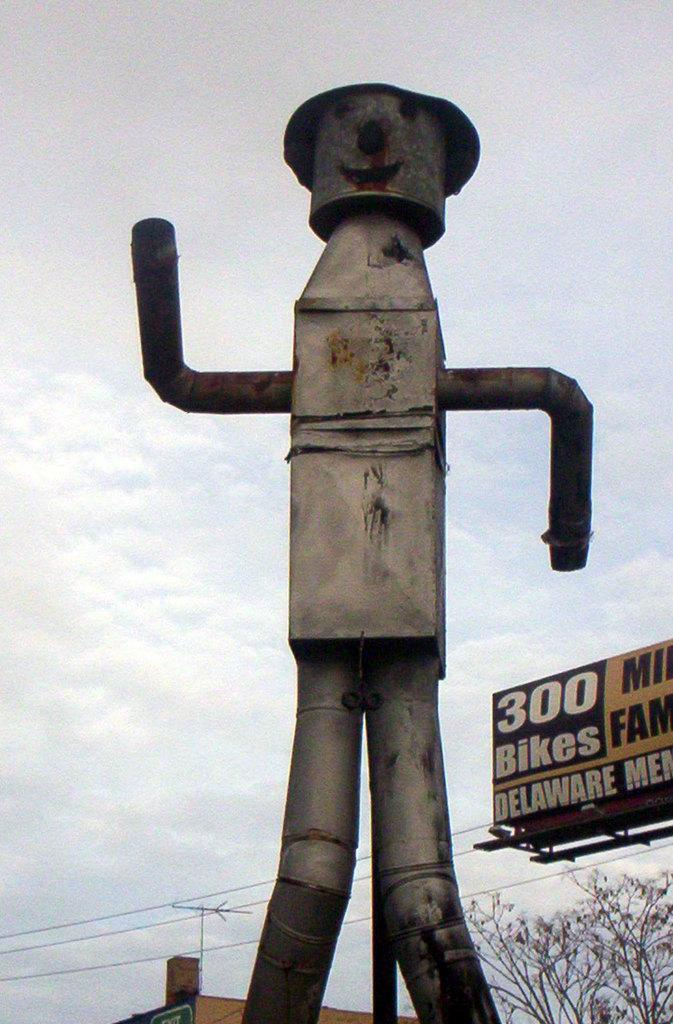What is the main structure in the image? There is a pole with pipes in the image. What can be seen on the right side of the image? There is a name board on the right side of the image. What type of vegetation is present in the image? There are trees in the image. What is visible in the background of the image? The sky is visible in the background of the image. What else can be seen in the image besides the pole and trees? There are wires in the image. What type of fruit is hanging from the pole in the image? There is no fruit hanging from the pole in the image; it is a pole with pipes. Are there any dolls visible in the image? There are no dolls present in the image. 